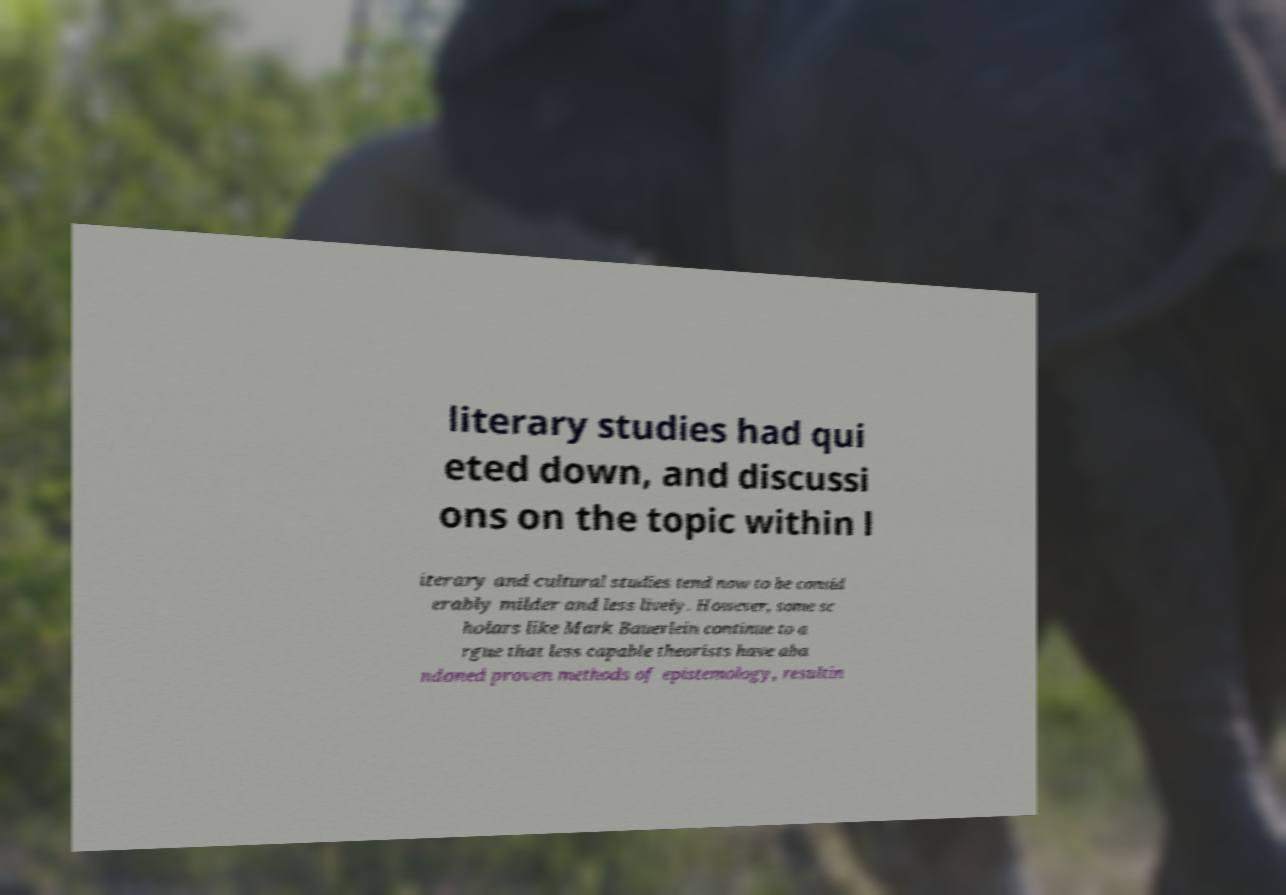I need the written content from this picture converted into text. Can you do that? literary studies had qui eted down, and discussi ons on the topic within l iterary and cultural studies tend now to be consid erably milder and less lively. However, some sc holars like Mark Bauerlein continue to a rgue that less capable theorists have aba ndoned proven methods of epistemology, resultin 